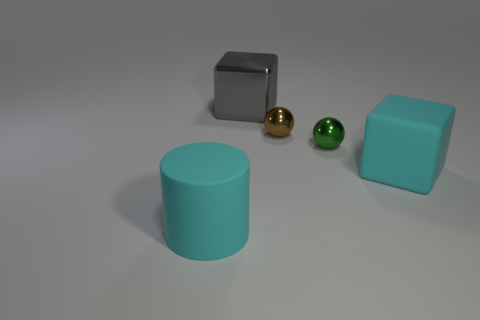What colors are the objects in the image? The objects display a variety of colors. There's a cylinder that's cyan, a cube that's gray, a small sphere that's green, another sphere that's golden, and finally, a cube with a slightly turquoise or teal color. 